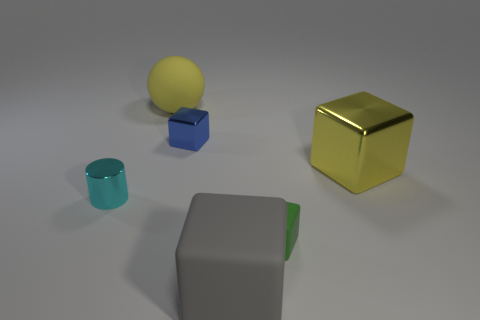There is a small metallic object behind the small shiny object that is left of the big yellow ball; what is its color?
Ensure brevity in your answer.  Blue. What number of large objects are either green metal cylinders or blue metallic objects?
Give a very brief answer. 0. There is a thing that is both in front of the big yellow metallic thing and on the left side of the small blue cube; what color is it?
Keep it short and to the point. Cyan. Is the gray object made of the same material as the small green block?
Provide a short and direct response. Yes. What is the shape of the large gray matte object?
Ensure brevity in your answer.  Cube. There is a big yellow object that is behind the large cube behind the big gray rubber cube; what number of yellow cubes are left of it?
Your answer should be very brief. 0. What is the color of the big rubber thing that is the same shape as the tiny green thing?
Give a very brief answer. Gray. The large yellow object in front of the large rubber thing behind the tiny metallic thing behind the cylinder is what shape?
Your answer should be compact. Cube. There is a object that is on the right side of the gray object and behind the green block; what size is it?
Keep it short and to the point. Large. Are there fewer large metal things than large cyan metal objects?
Your response must be concise. No. 